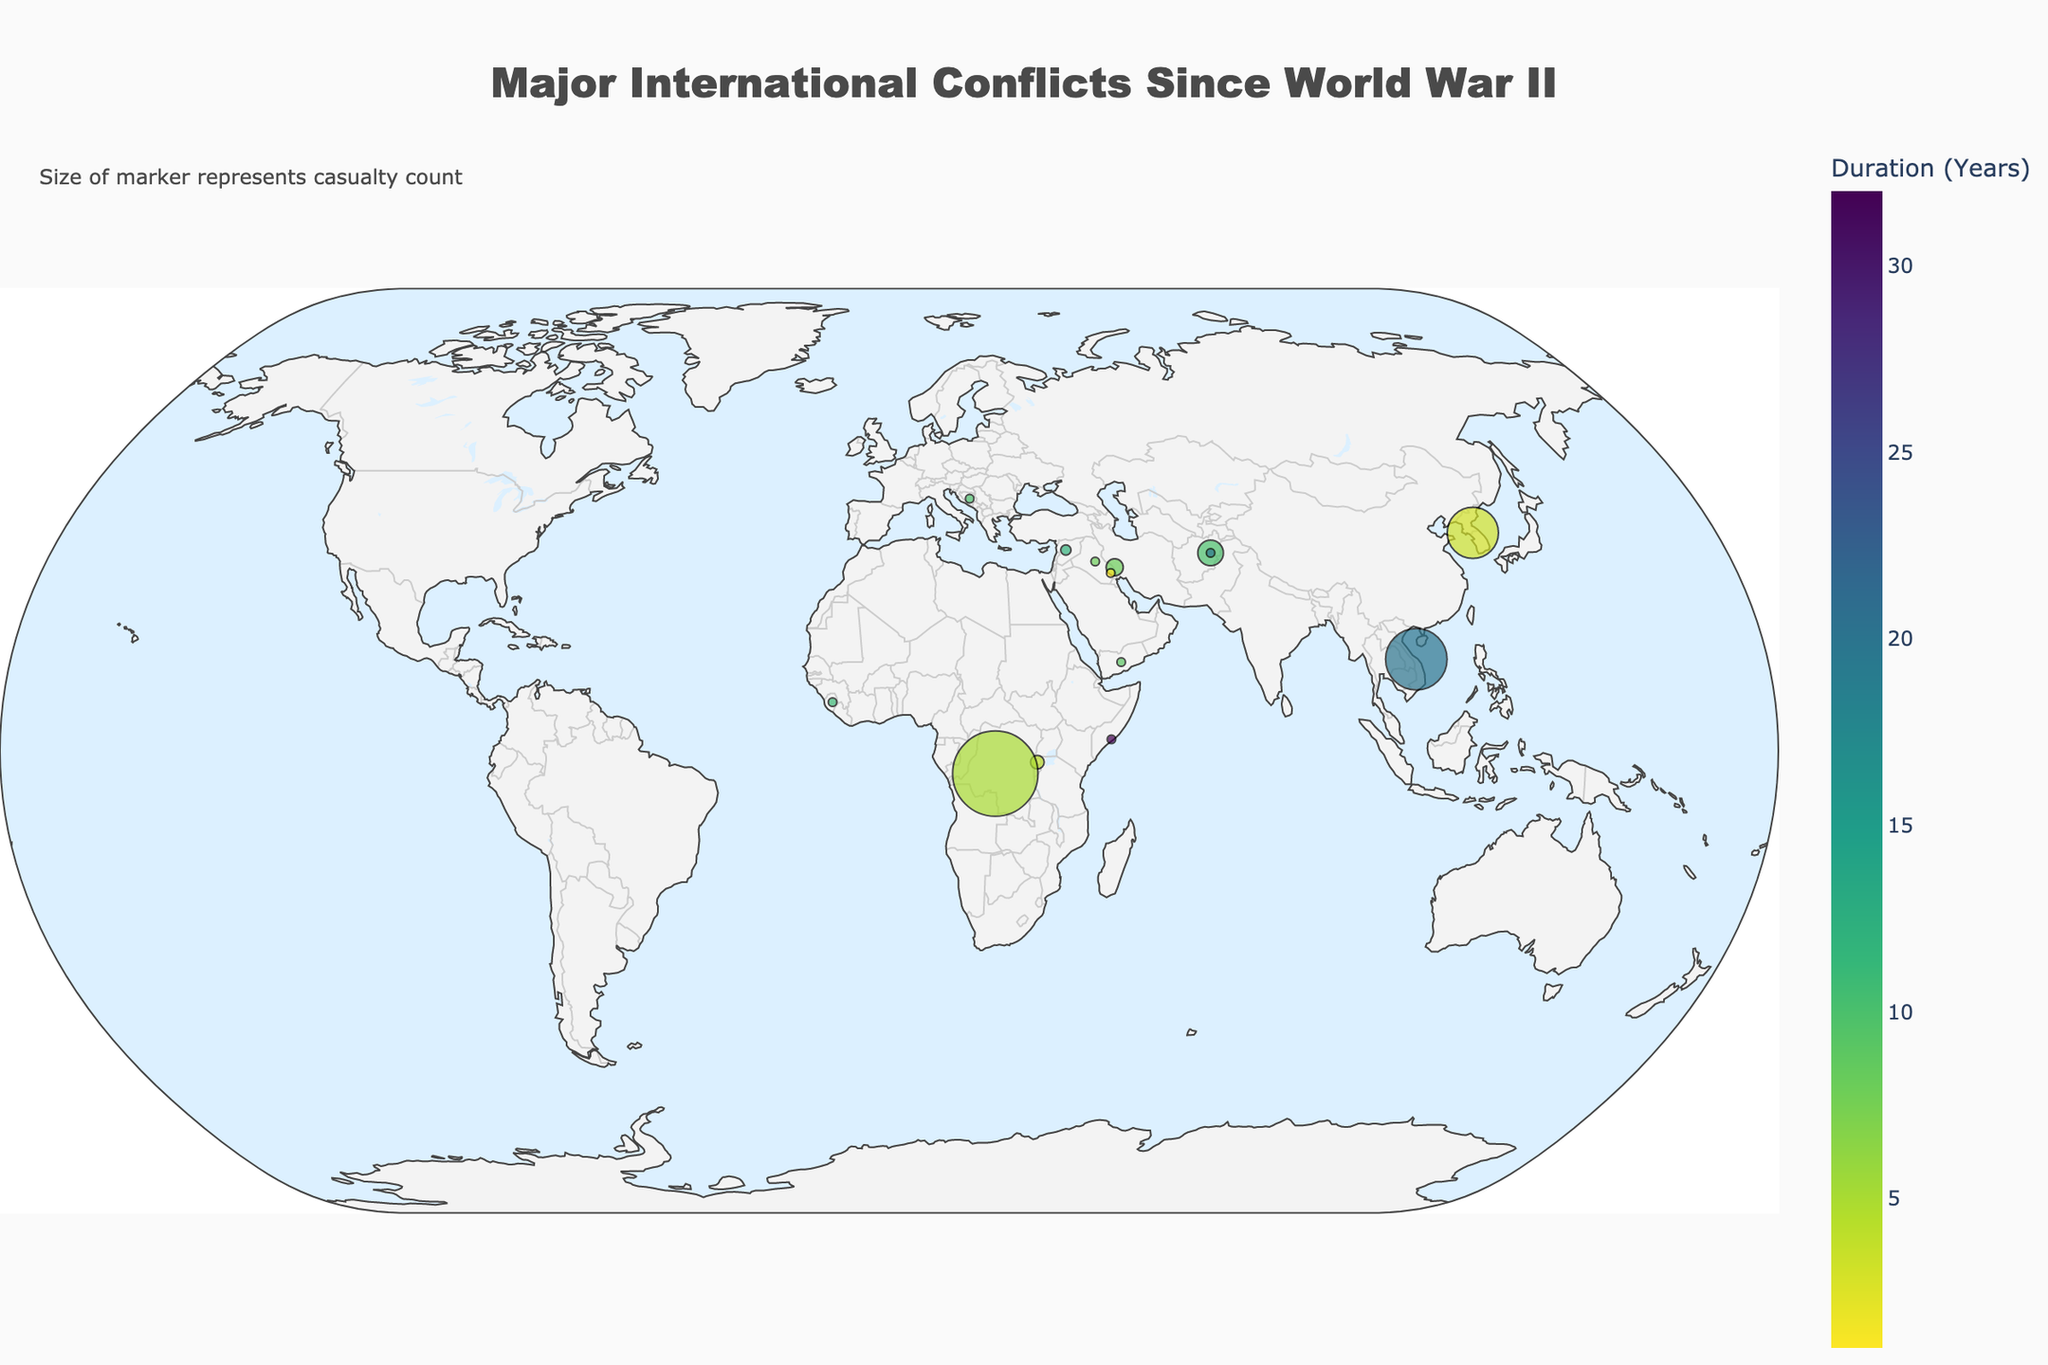Which conflict has the highest number of casualties, and how many? First, identify the conflict with the largest marker, as the marker size represents casualty count. Then, hover over that marker to see the number of casualties displayed in the hover text. The largest marker represents the Vietnam War with 3,600,000 casualties.
Answer: Vietnam War, 3,600,000 How long did the Korean War last? Locate the marker for the Korean War near the latitude 38.0 and longitude 127.0 on the map. Hover over the marker to see the hover text which states the duration. The Korean War lasted 3 years.
Answer: 3 years Which conflict lasted the shortest period, and for how long? Look for markers with the shortest duration (color is in Viridis scale). Hover over the markers to find the one with the shortest period. The First Gulf War lasted for 1 year.
Answer: First Gulf War, 1 year Compare the duration of the Vietnam War and the War in Afghanistan. Which one lasted longer and by how many years? Locate the markers for the Vietnam War and the War in Afghanistan, and hover over them to see the durations. The Vietnam War lasted 20 years, while the War in Afghanistan lasted 20 years. Since their durations are equal, neither lasted longer.
Answer: They lasted the same, 0 years difference Which conflict is ongoing with a high number of casualties? Identify the markers with "Ongoing" conflicts and evaluate their sizes. Hover over these markers to find out which one has the highest number of casualties. The Syrian Civil War is ongoing with 600,000 casualties.
Answer: Syrian Civil War, 600,000 What is the total number of years for conflicts in Africa represented on the map? Identify the markers in Africa (Rwanda, Sierra Leone, Somalia, and Congo). Sum their durations: Rwandan Civil War (4) + Sierra Leone Civil War (11) + Somali Civil War (32) + Second Congo War (5). The total duration is 4 + 11 + 32 + 5 = 52 years.
Answer: 52 years Which conflict had more casualties, the Soviet-Afghan War or the Iraq War? Locate the markers for both the Soviet-Afghan War and the Iraq War. Hover over the markers to see their casualties. The Soviet-Afghan War had 1,500,000 casualties, while the Iraq War had 460,000 casualties. Hence, the Soviet-Afghan War had more casualties.
Answer: Soviet-Afghan War What is the approximate location (latitude and longitude) of the conflict with the second-highest number of casualties? Determine the conflict with the second-largest marker by the size, which corresponds to the casualty count. Hover over the marker for an approximate location. For the Korean War, the approximate location is (38.0, 127.0).
Answer: (38.0, 127.0) How is the duration of the Yugoslav Wars compared to the Iran-Iraq War? Identify the markers for the Yugoslav Wars and Iran-Iraq War. Hover over each to find their durations. The Yugoslav Wars lasted for 10 years, while the Iran-Iraq War lasted for 8 years. Therefore, the Yugoslav Wars lasted longer by 2 years.
Answer: Yugoslav Wars by 2 years 